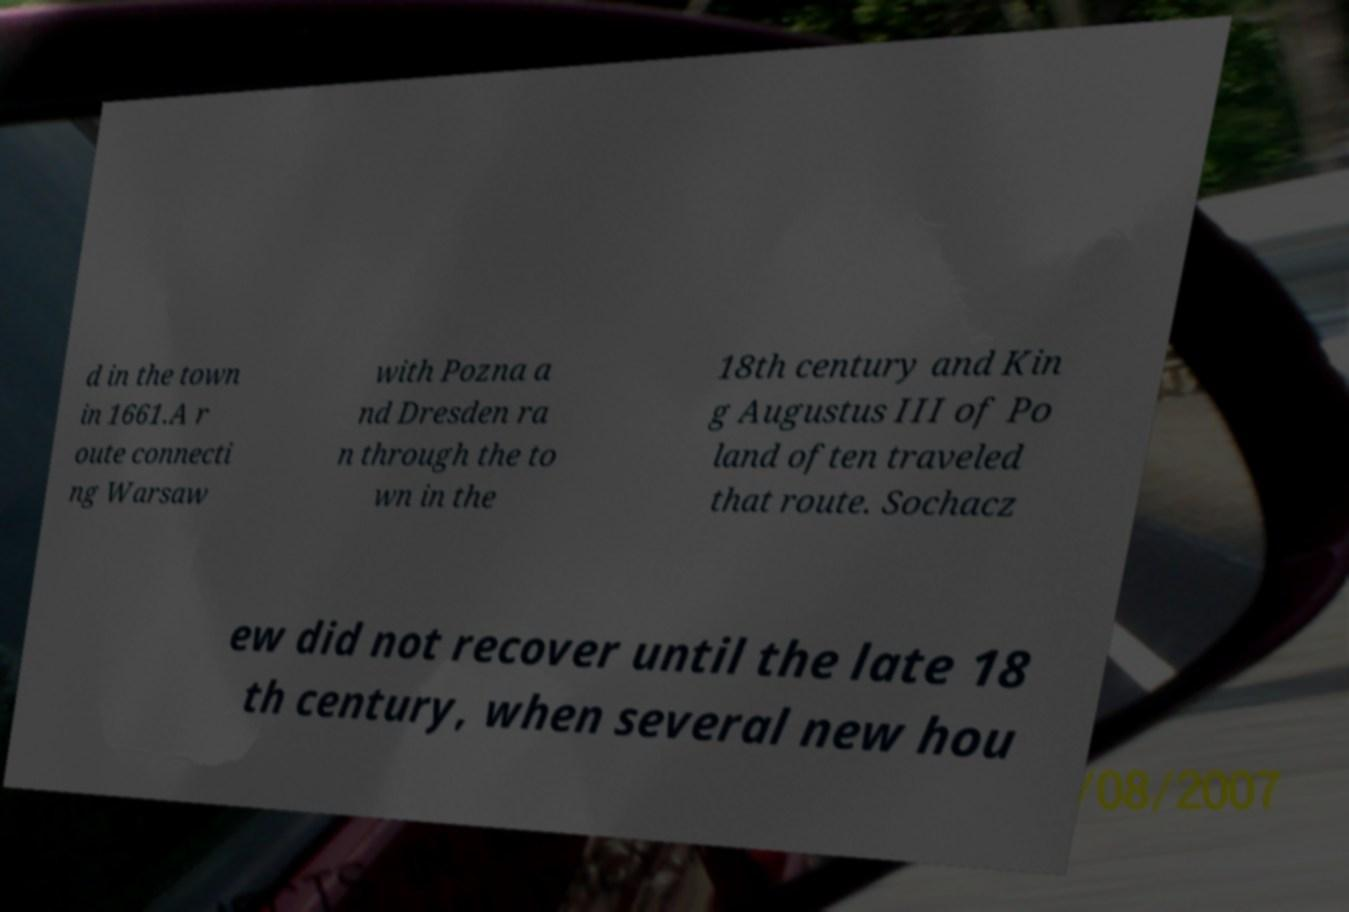I need the written content from this picture converted into text. Can you do that? d in the town in 1661.A r oute connecti ng Warsaw with Pozna a nd Dresden ra n through the to wn in the 18th century and Kin g Augustus III of Po land often traveled that route. Sochacz ew did not recover until the late 18 th century, when several new hou 